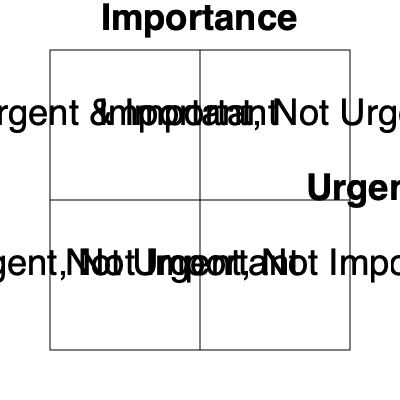As a freelancer managing multiple clients, you're using the Eisenhower Matrix to prioritize your tasks. Where would you place a task that's critical for a long-term project but doesn't have an immediate deadline? To answer this question, let's break down the Eisenhower Matrix and the given task:

1. The Eisenhower Matrix is divided into four quadrants based on urgency and importance:
   - Quadrant 1: Urgent and Important
   - Quadrant 2: Important, Not Urgent
   - Quadrant 3: Urgent, Not Important
   - Quadrant 4: Not Urgent, Not Important

2. Analyze the given task:
   - It's critical for a long-term project, which means it's important.
   - It doesn't have an immediate deadline, which means it's not urgent.

3. Based on these characteristics, we can determine that the task is:
   - Important (critical for a long-term project)
   - Not Urgent (no immediate deadline)

4. Looking at the matrix, tasks that are important but not urgent fall into Quadrant 2: Important, Not Urgent.

5. For freelancers, tasks in this quadrant are crucial for long-term success and should be prioritized to prevent them from becoming urgent later.

Therefore, the task should be placed in the "Important, Not Urgent" quadrant of the Eisenhower Matrix.
Answer: Important, Not Urgent quadrant 